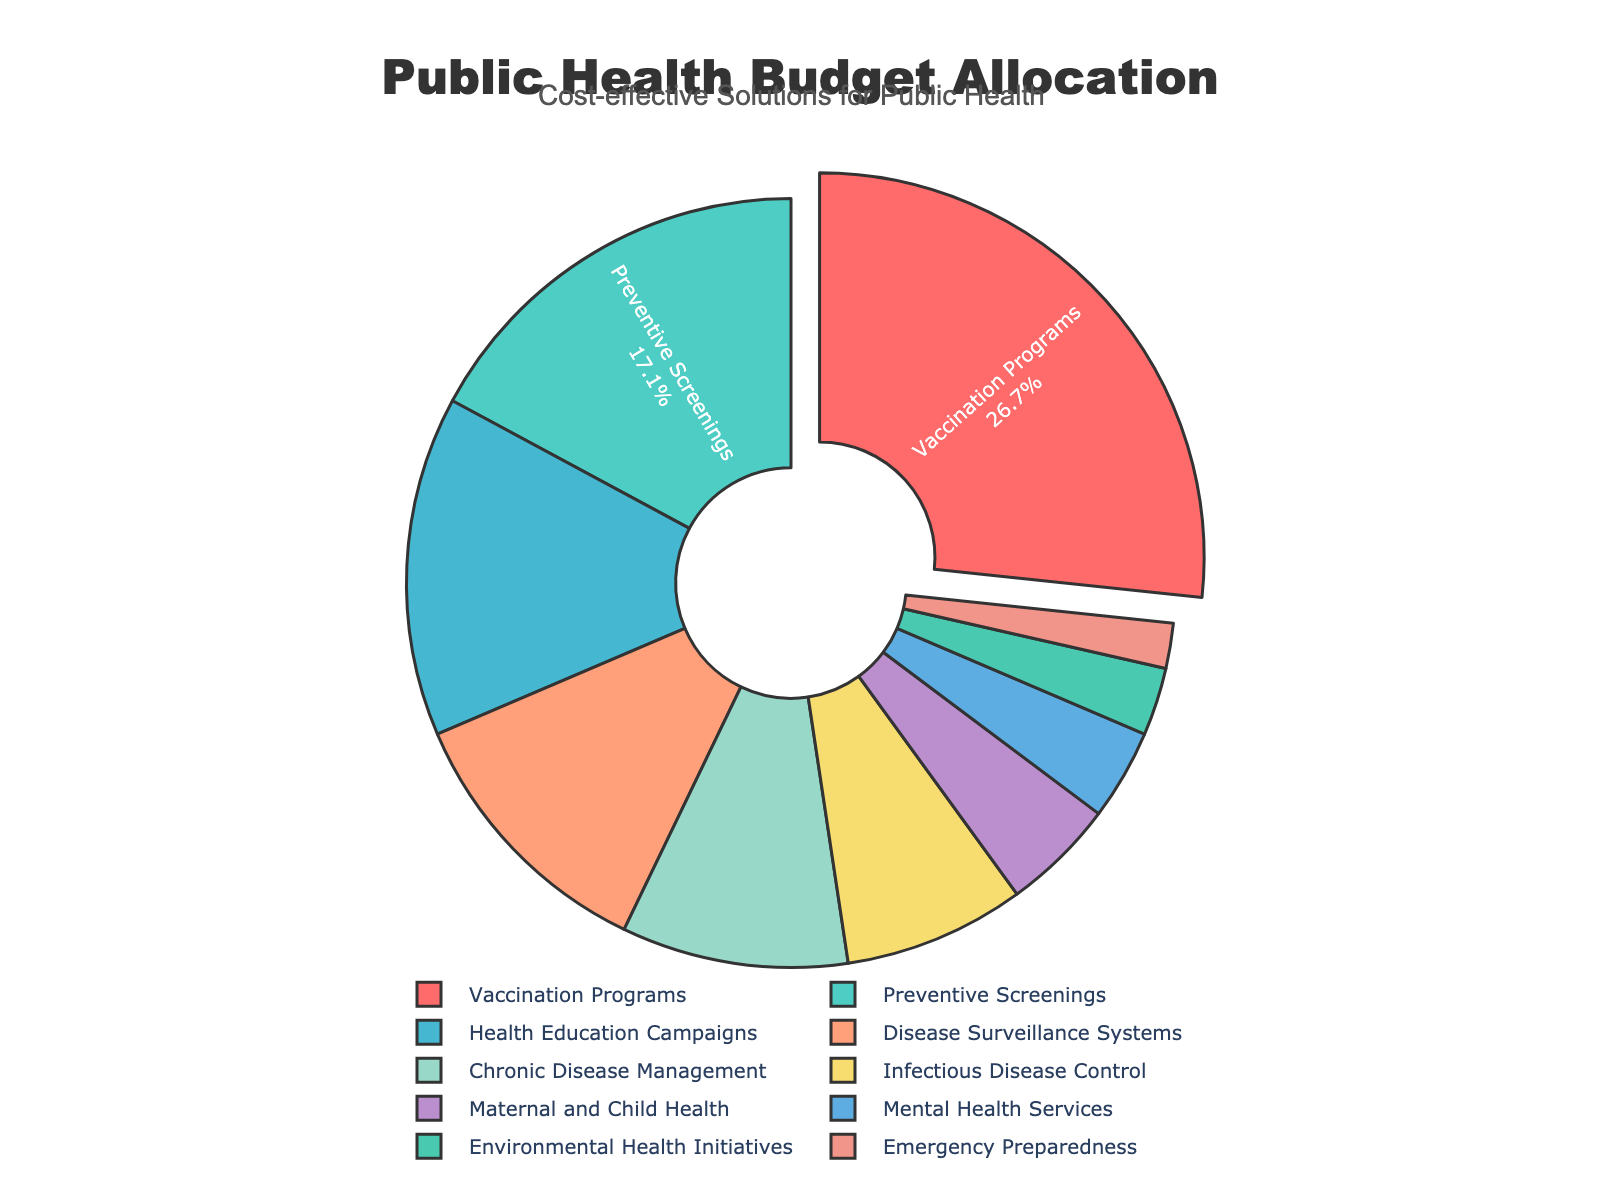Which intervention strategy receives the highest budget allocation? The highest budget allocation can be identified by looking for the largest pie slice that is also pulled out slightly from the center. This slice represents Vaccination Programs, which has a budget allocation of 28%.
Answer: Vaccination Programs Which intervention strategies receive equal or less than 5% of the budget allocation? We need to identify the slices labeled with 5% or less. The slices for Maternal and Child Health (5%), Mental Health Services (4%), Environmental Health Initiatives (3%), and Emergency Preparedness (2%) fall into this category.
Answer: Maternal and Child Health, Mental Health Services, Environmental Health Initiatives, Emergency Preparedness What is the sum of the budget allocations for Preventive Screenings and Health Education Campaigns? The budget allocation for Preventive Screenings is 18% and for Health Education Campaigns is 15%. The sum of these two allocations is 18% + 15% = 33%.
Answer: 33% Which intervention strategies combined have a higher budget allocation than Infectious Disease Control? Infectious Disease Control has a budget allocation of 8%. We need to find combinations of other strategies that sum to more than 8%. Any single strategy categorized above 8% will answer this, or combinations that surpass 8%. For instance, Chronic Disease Management (10%), or Health Education Campaigns (15%).
Answer: Health Education Campaigns, Chronic Disease Management Is the budget allocation for Disease Surveillance Systems greater than for Mental Health Services and Environmental Health Initiatives combined? Disease Surveillance Systems has a budget allocation of 12%. Mental Health Services has 4%, and Environmental Health Initiatives has 3%, which sum to 7%. Since 12% is greater than 7%, the answer is yes.
Answer: Yes Which slice of the pie chart represents the smallest portion of the budget? The smallest slice of the pie chart is the one labeled with the smallest budget allocation percentage, which is Emergency Preparedness with 2%.
Answer: Emergency Preparedness Of the strategies listed, which has a greater budget allocation: Chronic Disease Management or Disease Surveillance Systems? Chronic Disease Management has a budget allocation of 10%. Disease Surveillance Systems have 12%. Therefore, Disease Surveillance Systems have a greater budget allocation.
Answer: Disease Surveillance Systems What percentage of the budget is allocated to Vaccination Programs and Environmental Health Initiatives combined? Vaccination Programs have a 28% allocation, and Environmental Health Initiatives have 3%. Combined, they total 28% + 3% = 31%.
Answer: 31% How much more percentage is allocated to Health Education Campaigns compared to Mental Health Services? Health Education Campaigns receive 15%, and Mental Health Services receive 4%. The difference is 15% - 4% = 11%.
Answer: 11% Which intervention strategy has a budget allocation closest to Preventive Screenings? Preventive Screenings have an 18% allocation. The strategy closest to this number is Health Education Campaigns with a 15% allocation.
Answer: Health Education Campaigns 